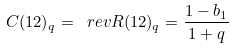<formula> <loc_0><loc_0><loc_500><loc_500>C ( 1 2 ) _ { q } = \ r e v { R ( 1 2 ) _ { q } } = \frac { 1 - b _ { 1 } } { 1 + q }</formula> 